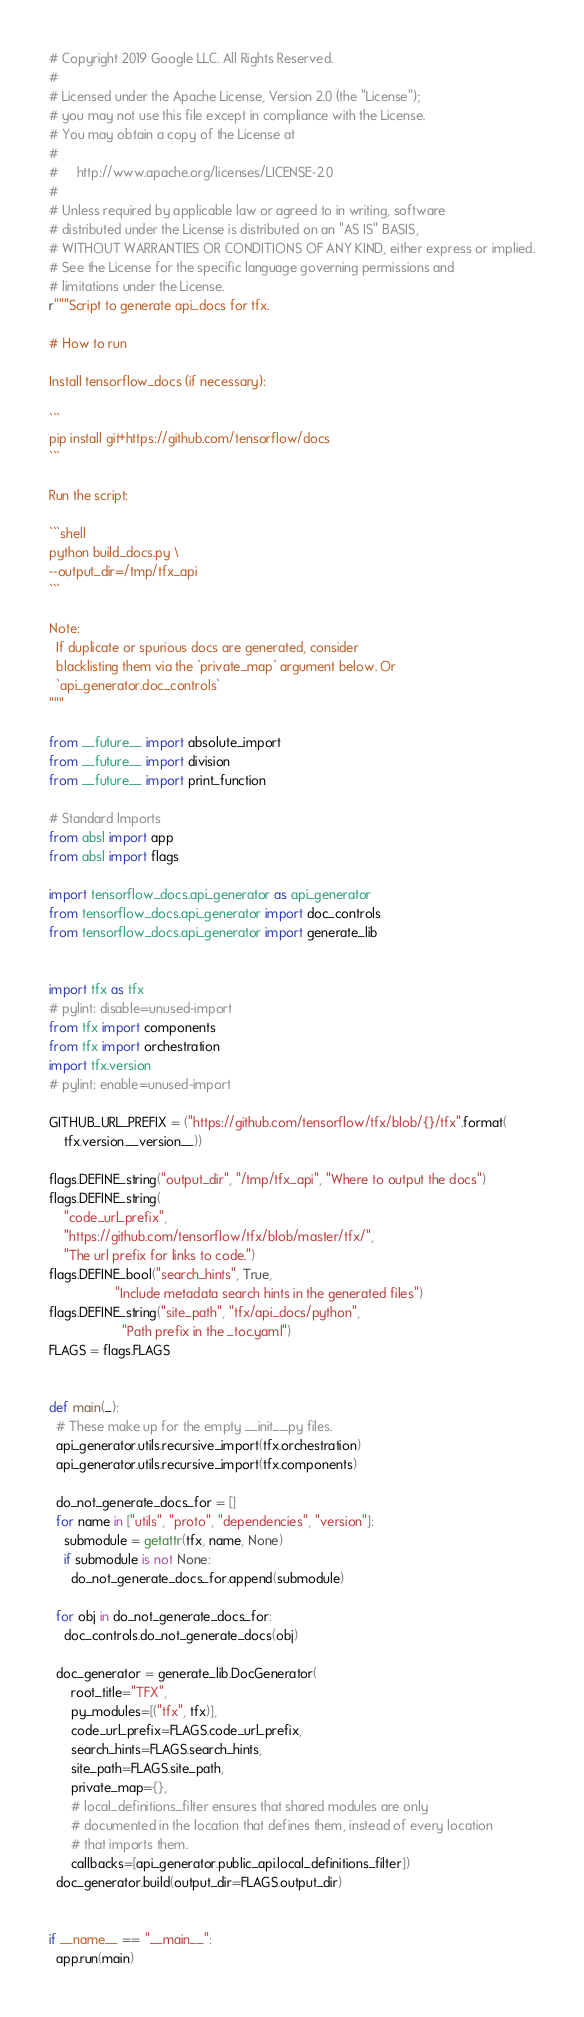<code> <loc_0><loc_0><loc_500><loc_500><_Python_># Copyright 2019 Google LLC. All Rights Reserved.
#
# Licensed under the Apache License, Version 2.0 (the "License");
# you may not use this file except in compliance with the License.
# You may obtain a copy of the License at
#
#     http://www.apache.org/licenses/LICENSE-2.0
#
# Unless required by applicable law or agreed to in writing, software
# distributed under the License is distributed on an "AS IS" BASIS,
# WITHOUT WARRANTIES OR CONDITIONS OF ANY KIND, either express or implied.
# See the License for the specific language governing permissions and
# limitations under the License.
r"""Script to generate api_docs for tfx.

# How to run

Install tensorflow_docs (if necessary):

```
pip install git+https://github.com/tensorflow/docs
```

Run the script:

```shell
python build_docs.py \
--output_dir=/tmp/tfx_api
```

Note:
  If duplicate or spurious docs are generated, consider
  blacklisting them via the `private_map` argument below. Or
  `api_generator.doc_controls`
"""

from __future__ import absolute_import
from __future__ import division
from __future__ import print_function

# Standard Imports
from absl import app
from absl import flags

import tensorflow_docs.api_generator as api_generator
from tensorflow_docs.api_generator import doc_controls
from tensorflow_docs.api_generator import generate_lib


import tfx as tfx
# pylint: disable=unused-import
from tfx import components
from tfx import orchestration
import tfx.version
# pylint: enable=unused-import

GITHUB_URL_PREFIX = ("https://github.com/tensorflow/tfx/blob/{}/tfx".format(
    tfx.version.__version__))

flags.DEFINE_string("output_dir", "/tmp/tfx_api", "Where to output the docs")
flags.DEFINE_string(
    "code_url_prefix",
    "https://github.com/tensorflow/tfx/blob/master/tfx/",
    "The url prefix for links to code.")
flags.DEFINE_bool("search_hints", True,
                  "Include metadata search hints in the generated files")
flags.DEFINE_string("site_path", "tfx/api_docs/python",
                    "Path prefix in the _toc.yaml")
FLAGS = flags.FLAGS


def main(_):
  # These make up for the empty __init__.py files.
  api_generator.utils.recursive_import(tfx.orchestration)
  api_generator.utils.recursive_import(tfx.components)

  do_not_generate_docs_for = []
  for name in ["utils", "proto", "dependencies", "version"]:
    submodule = getattr(tfx, name, None)
    if submodule is not None:
      do_not_generate_docs_for.append(submodule)

  for obj in do_not_generate_docs_for:
    doc_controls.do_not_generate_docs(obj)

  doc_generator = generate_lib.DocGenerator(
      root_title="TFX",
      py_modules=[("tfx", tfx)],
      code_url_prefix=FLAGS.code_url_prefix,
      search_hints=FLAGS.search_hints,
      site_path=FLAGS.site_path,
      private_map={},
      # local_definitions_filter ensures that shared modules are only
      # documented in the location that defines them, instead of every location
      # that imports them.
      callbacks=[api_generator.public_api.local_definitions_filter])
  doc_generator.build(output_dir=FLAGS.output_dir)


if __name__ == "__main__":
  app.run(main)
</code> 